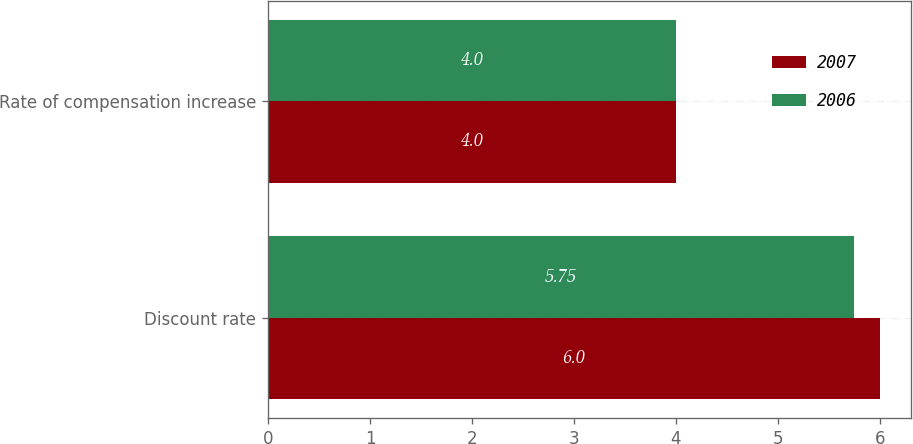<chart> <loc_0><loc_0><loc_500><loc_500><stacked_bar_chart><ecel><fcel>Discount rate<fcel>Rate of compensation increase<nl><fcel>2007<fcel>6<fcel>4<nl><fcel>2006<fcel>5.75<fcel>4<nl></chart> 